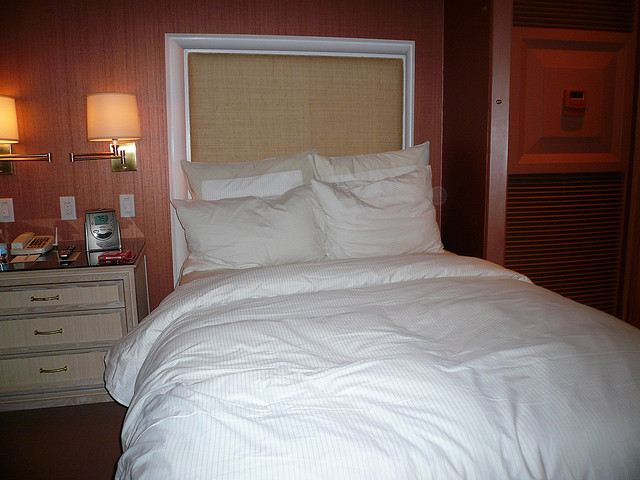What color scheme is present in the bedroom? The bedroom predominantly features a soothing color scheme with neutral and soft tones. The walls are a gentle mauve, and the bedding is a pristine white, which creates a calming and elegant ambiance in the room. 